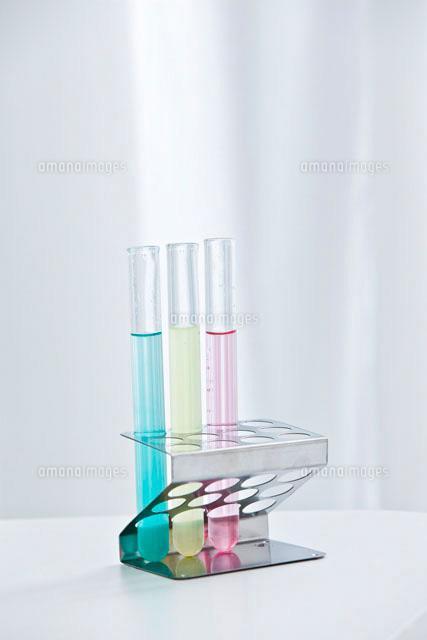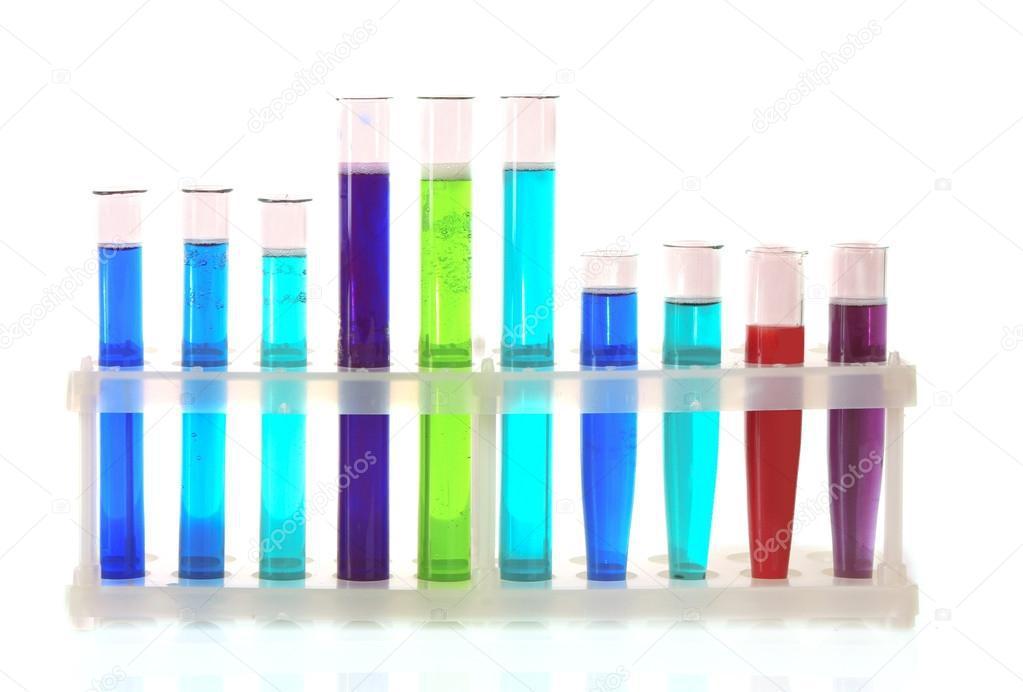The first image is the image on the left, the second image is the image on the right. Assess this claim about the two images: "The left image shows a beaker of purple liquid to the front and right of a stand containing test tubes, at least two with purple liquid in them.". Correct or not? Answer yes or no. No. The first image is the image on the left, the second image is the image on the right. For the images displayed, is the sentence "The containers in each of the images are all long and slender." factually correct? Answer yes or no. Yes. 